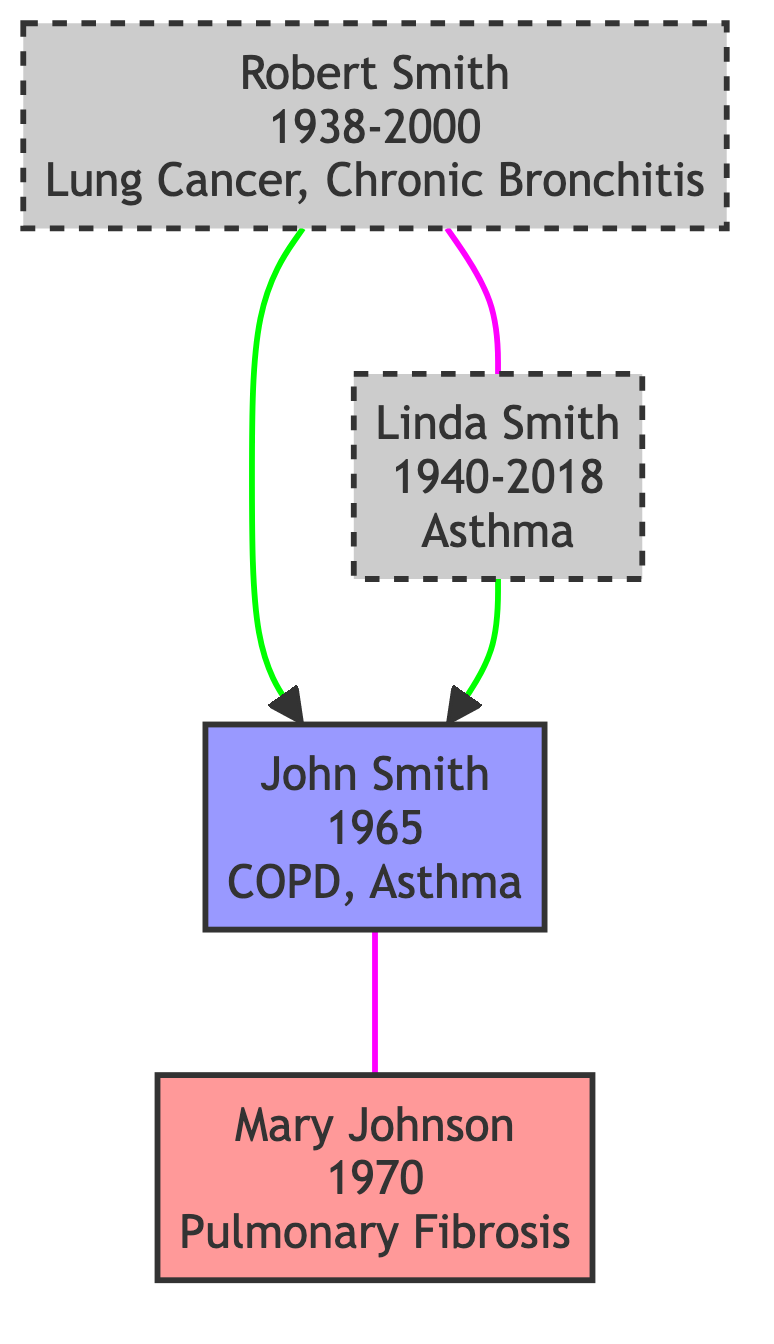What is the birth year of John Smith? The diagram shows the node for John Smith, which clearly states "1965" beside his name.
Answer: 1965 How many diagnoses does Robert Smith have? By examining the node for Robert Smith, we can see that there are two conditions listed: Lung Cancer and Chronic Bronchitis.
Answer: 2 What condition was Linda Smith diagnosed with? Looking at the node for Linda Smith, it specifies that she was diagnosed with Asthma.
Answer: Asthma Who is the spouse of John Smith? The diagram indicates a connection (spousal relationship) between John Smith and Mary Johnson, denoting Mary as John's spouse.
Answer: Mary Johnson Which year was Mary Johnson born? The diagram provides the birth year for Mary Johnson directly, listed as "1970."
Answer: 1970 Who diagnosed with COPD in the family tree? The only patient diagnosed with Chronic Obstructive Pulmonary Disease (COPD) is John Smith, as noted in his diagnosis list.
Answer: John Smith What is the relationship between Robert Smith and Linda Smith? The diagram shows they are linked as "spouse," meaning they are married to each other.
Answer: Spouse What is the death year of Linda Smith? The death year for Linda Smith is noted in her node as "2018."
Answer: 2018 Which disease has only one individual diagnosed with it in the family tree? The only individual diagnosed with Pulmonary Fibrosis is Mary Johnson; thus, it is unique to her in this data set.
Answer: Pulmonary Fibrosis 